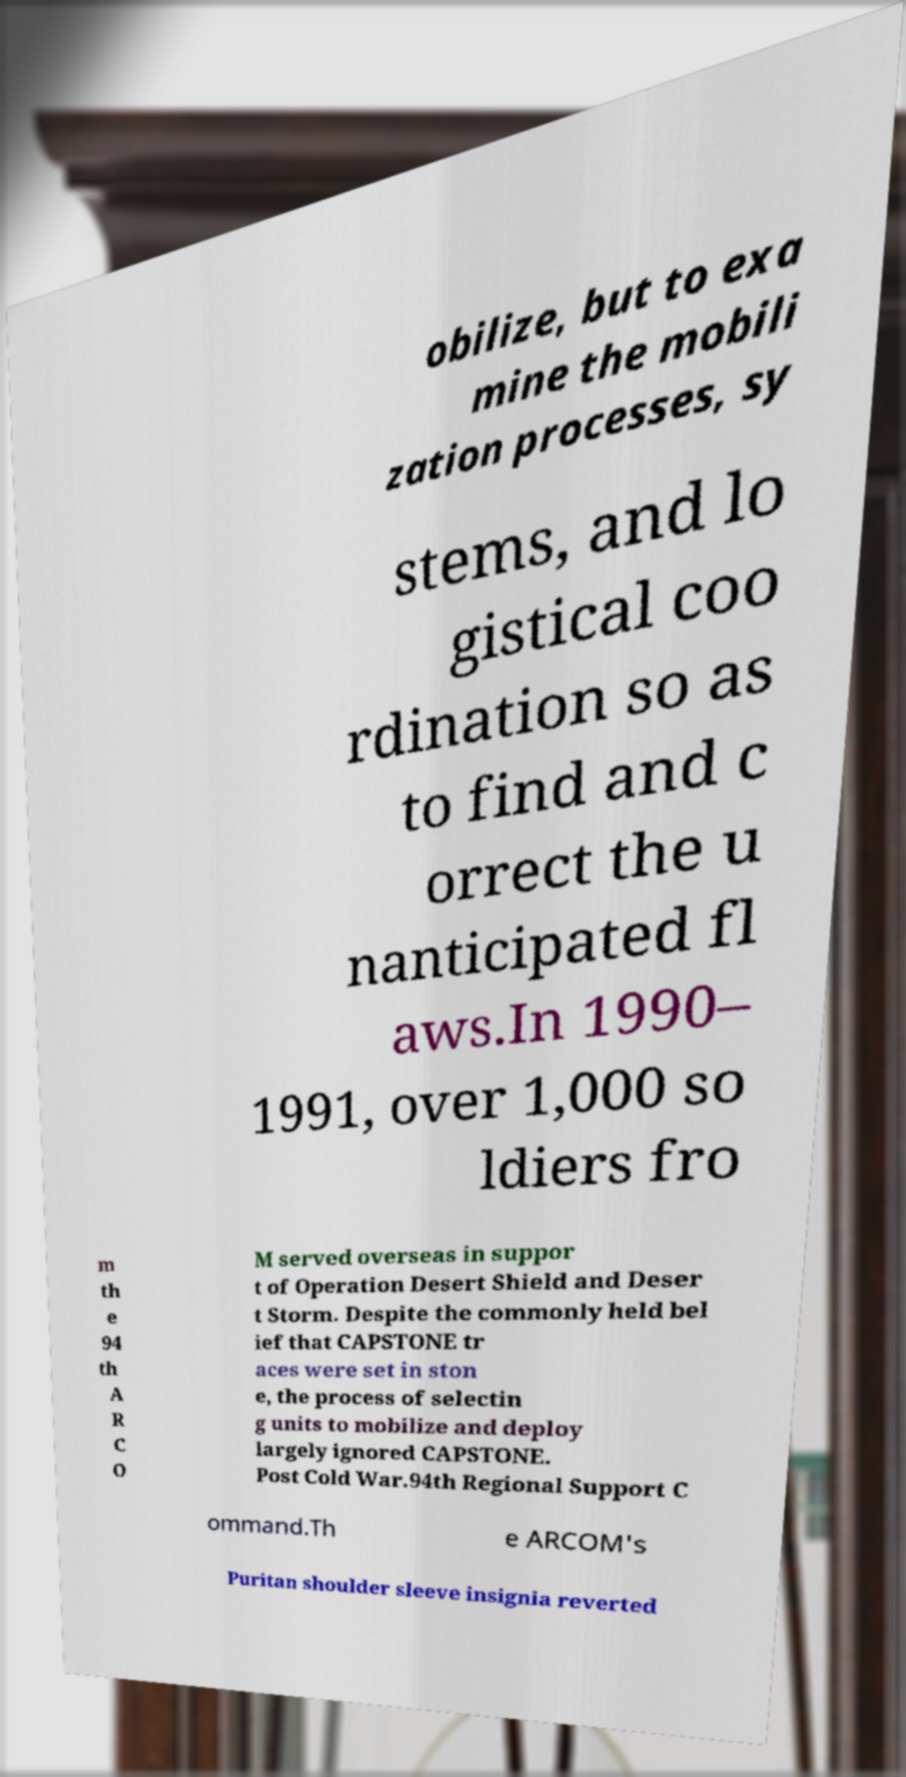I need the written content from this picture converted into text. Can you do that? obilize, but to exa mine the mobili zation processes, sy stems, and lo gistical coo rdination so as to find and c orrect the u nanticipated fl aws.In 1990– 1991, over 1,000 so ldiers fro m th e 94 th A R C O M served overseas in suppor t of Operation Desert Shield and Deser t Storm. Despite the commonly held bel ief that CAPSTONE tr aces were set in ston e, the process of selectin g units to mobilize and deploy largely ignored CAPSTONE. Post Cold War.94th Regional Support C ommand.Th e ARCOM's Puritan shoulder sleeve insignia reverted 